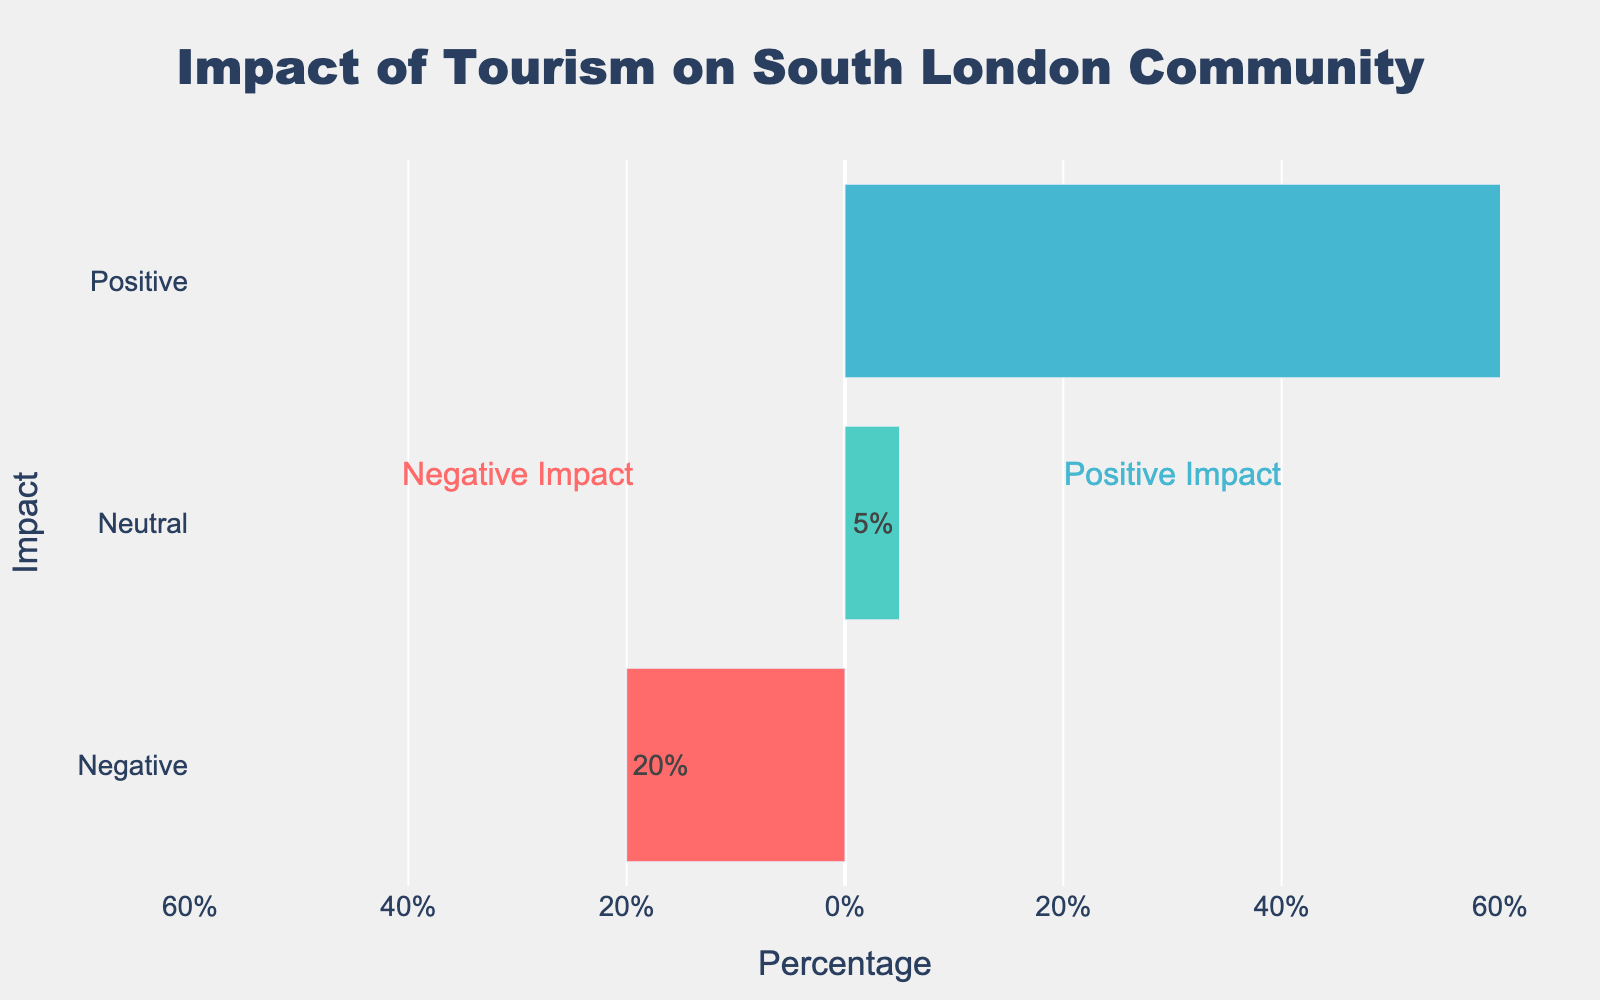What is the total percentage of positive impacts of tourism as indicated in the chart? The positive impacts include percentages of 35%, 25%, and 15%. By summing these, we get 35 + 25 + 15 which equals 75.
Answer: 75% How does the percentage of positive impacts compare to negative impacts? The total percentage of positive impacts is 75%, while the total percentage of negative impacts is 20%. 75% is greater than 20%.
Answer: Positive impacts are greater Which impact category is shown in green and what is its percentage? The neutral impact is shown in green with a percentage of 5%.
Answer: Neutral, 5% What is the difference in percentage between rising property prices and cost of living and increased revenue for local businesses? The percentage of rising property prices and cost of living is 10%, while the percentage for increased revenue is 35%. The difference is 35 - 10 which equals 25.
Answer: 25% What visual features indicate the most significant impact of tourism according to residents? The longest bar represents the most significant impact, which is a positive impact of increased revenue for local businesses at 35%.
Answer: Length of the bar, 35% How is enhanced cultural exchange and diversity represented in terms of color and position in the chart? Enhanced cultural exchange and diversity is represented in blue and positioned among the positive impacts.
Answer: Blue, positive impacts How do the positive and negative impacts compare numerically on the chart? Positive impacts add up to 75%, while negative impacts add up to 20%. 75% is significantly higher than 20%.
Answer: Positive impacts are higher Which specific negative impact is reported at the same percentage as noise and environmental pollution, and how is it visually represented? Loss of community cohesion is reported at the same percentage (5%) as noise and environmental pollution. Both are represented as short red bars.
Answer: Loss of community cohesion, visually represented as red What is the total sum of impacts categorized as neutral and negative? The neutral impact is 5%, and the negative impacts sum to 20%. Adding these together gives 5 + 20 which equals 25.
Answer: 25% If you combine the percentages of improved infrastructure and public services with enhanced cultural exchange and diversity, what is the result? Improved infrastructure and public services have a percentage of 25%, while enhanced cultural exchange and diversity have a percentage of 15%. Adding them together gives 25 + 15 which equals 40.
Answer: 40% 